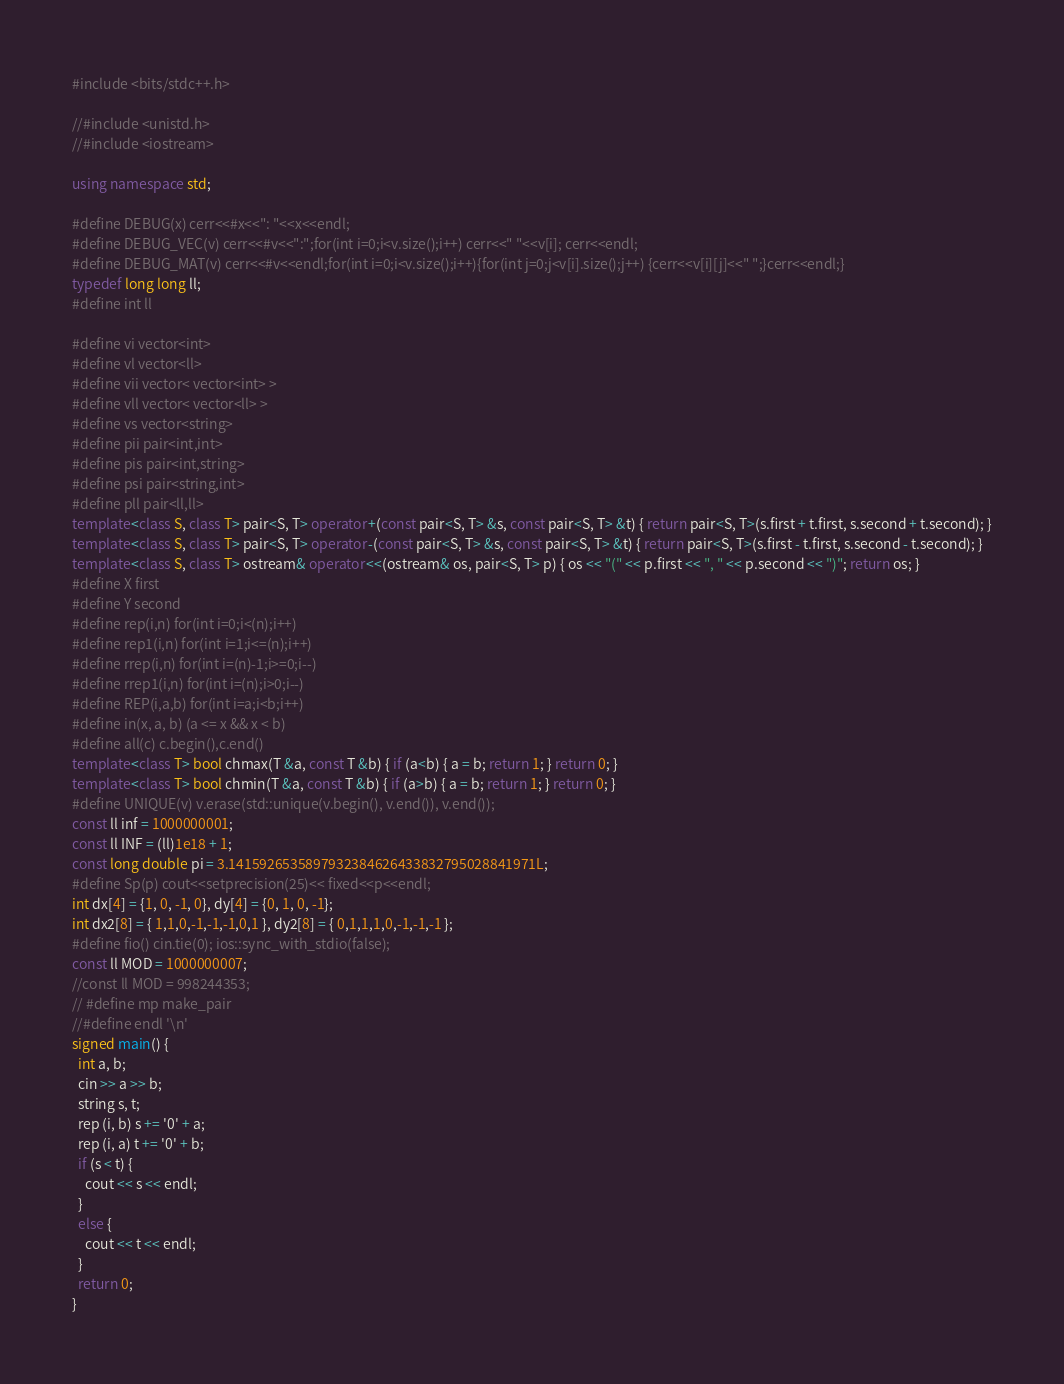Convert code to text. <code><loc_0><loc_0><loc_500><loc_500><_C++_>#include <bits/stdc++.h>
 
//#include <unistd.h>
//#include <iostream>
 
using namespace std;
 
#define DEBUG(x) cerr<<#x<<": "<<x<<endl;
#define DEBUG_VEC(v) cerr<<#v<<":";for(int i=0;i<v.size();i++) cerr<<" "<<v[i]; cerr<<endl;
#define DEBUG_MAT(v) cerr<<#v<<endl;for(int i=0;i<v.size();i++){for(int j=0;j<v[i].size();j++) {cerr<<v[i][j]<<" ";}cerr<<endl;}
typedef long long ll;
#define int ll
 
#define vi vector<int>
#define vl vector<ll>
#define vii vector< vector<int> >
#define vll vector< vector<ll> >
#define vs vector<string>
#define pii pair<int,int>
#define pis pair<int,string>
#define psi pair<string,int>
#define pll pair<ll,ll>
template<class S, class T> pair<S, T> operator+(const pair<S, T> &s, const pair<S, T> &t) { return pair<S, T>(s.first + t.first, s.second + t.second); }
template<class S, class T> pair<S, T> operator-(const pair<S, T> &s, const pair<S, T> &t) { return pair<S, T>(s.first - t.first, s.second - t.second); }
template<class S, class T> ostream& operator<<(ostream& os, pair<S, T> p) { os << "(" << p.first << ", " << p.second << ")"; return os; }
#define X first
#define Y second
#define rep(i,n) for(int i=0;i<(n);i++)
#define rep1(i,n) for(int i=1;i<=(n);i++)
#define rrep(i,n) for(int i=(n)-1;i>=0;i--)
#define rrep1(i,n) for(int i=(n);i>0;i--)
#define REP(i,a,b) for(int i=a;i<b;i++)
#define in(x, a, b) (a <= x && x < b)
#define all(c) c.begin(),c.end()
template<class T> bool chmax(T &a, const T &b) { if (a<b) { a = b; return 1; } return 0; }
template<class T> bool chmin(T &a, const T &b) { if (a>b) { a = b; return 1; } return 0; }
#define UNIQUE(v) v.erase(std::unique(v.begin(), v.end()), v.end());
const ll inf = 1000000001;
const ll INF = (ll)1e18 + 1;
const long double pi = 3.1415926535897932384626433832795028841971L;
#define Sp(p) cout<<setprecision(25)<< fixed<<p<<endl;
int dx[4] = {1, 0, -1, 0}, dy[4] = {0, 1, 0, -1};
int dx2[8] = { 1,1,0,-1,-1,-1,0,1 }, dy2[8] = { 0,1,1,1,0,-1,-1,-1 };
#define fio() cin.tie(0); ios::sync_with_stdio(false);
const ll MOD = 1000000007;
//const ll MOD = 998244353;
// #define mp make_pair
//#define endl '\n'
signed main() {
  int a, b;
  cin >> a >> b;
  string s, t;
  rep (i, b) s += '0' + a;
  rep (i, a) t += '0' + b;
  if (s < t) {
    cout << s << endl;
  }
  else {
    cout << t << endl;
  }
  return 0;
}</code> 